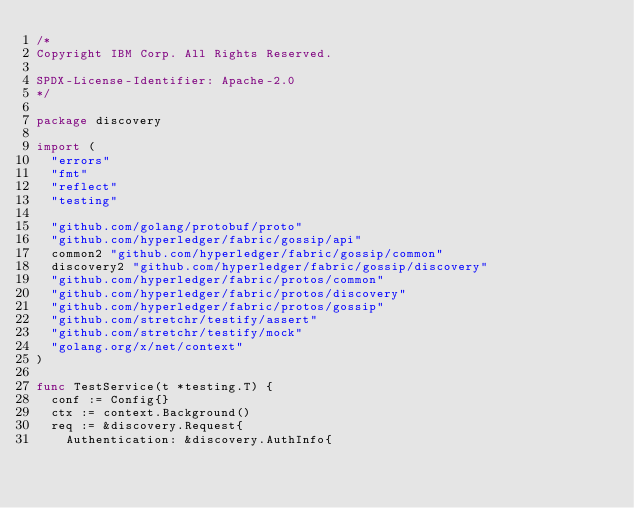<code> <loc_0><loc_0><loc_500><loc_500><_Go_>/*
Copyright IBM Corp. All Rights Reserved.

SPDX-License-Identifier: Apache-2.0
*/

package discovery

import (
	"errors"
	"fmt"
	"reflect"
	"testing"

	"github.com/golang/protobuf/proto"
	"github.com/hyperledger/fabric/gossip/api"
	common2 "github.com/hyperledger/fabric/gossip/common"
	discovery2 "github.com/hyperledger/fabric/gossip/discovery"
	"github.com/hyperledger/fabric/protos/common"
	"github.com/hyperledger/fabric/protos/discovery"
	"github.com/hyperledger/fabric/protos/gossip"
	"github.com/stretchr/testify/assert"
	"github.com/stretchr/testify/mock"
	"golang.org/x/net/context"
)

func TestService(t *testing.T) {
	conf := Config{}
	ctx := context.Background()
	req := &discovery.Request{
		Authentication: &discovery.AuthInfo{</code> 